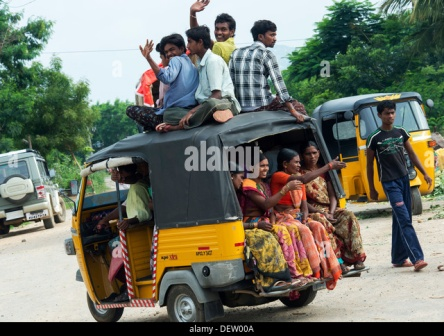Describe in detail a realistic long scenario involving the people from the image? It was a festive day in the village; the local fair had returned after a gap of several years, promising a day full of fun and frolic. Families and friends flocked to the fairground early in the morning, eager to partake in the festivities. Among them was a close-knit group of friends, including the ones in the picture. They spent the day at the fair, indulging in various traditional games, savoring local delicacies, and relishing the vibrant performances acted out by street artists and musicians.

As the sun began to set, they realized the day had flown by too quickly. Reluctant to part ways, they decided to share an auto rickshaw ride home, determined to extend their cheerful day just a bit longer. The rickshaw, which was already quite full, became the epicenter of their extended celebration. A few adventurous souls clambered onto the roof, egged on by their friends.

As they journeyed through the winding village roads, the air was filled with laughter and songs. The young men on the roof waved enthusiastically at passersby and praised the driver for his skillful navigation. Inside, the passengers exchanged stories about their favorite moments from the day. Their collective excitement was palpable, turning what could have been an ordinary ride into a memorable conclusion to a perfect day.

The rickshaw trundled along, kicking up small clouds of dust as it moved. The serene sounds of the countryside were occasionally interrupted by the chimes of the bell attached to the temple they passed by. Villagers smiled and waved, some taking out their phones to capture the joyful moment. By the time the rickshaw dropped each passenger off, their spirits were high, filled with a shared sense of camaraderie and joy. Each one went to bed that night with a smile, content with the day well spent and memories made. 